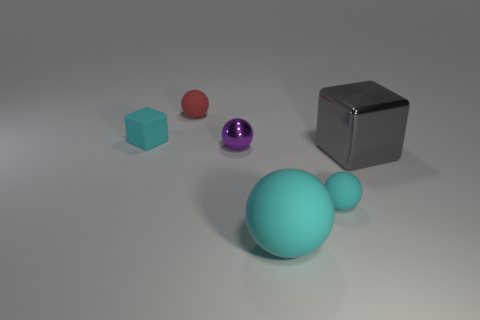How many other objects are the same shape as the large cyan rubber object? 3 